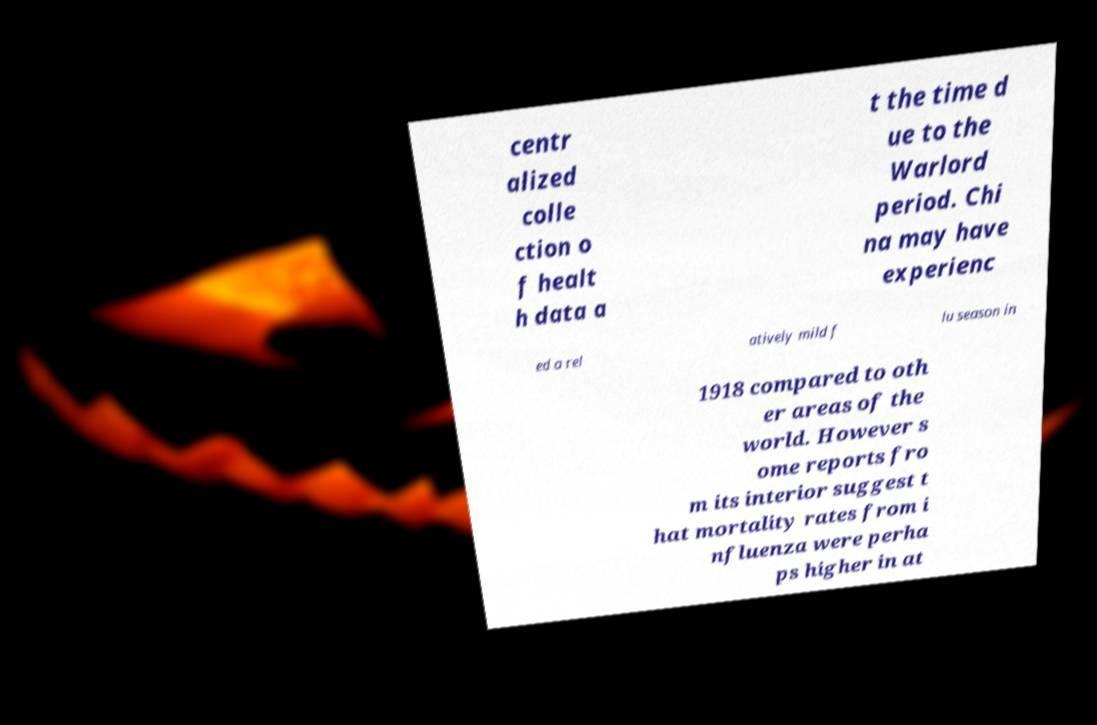Can you read and provide the text displayed in the image?This photo seems to have some interesting text. Can you extract and type it out for me? centr alized colle ction o f healt h data a t the time d ue to the Warlord period. Chi na may have experienc ed a rel atively mild f lu season in 1918 compared to oth er areas of the world. However s ome reports fro m its interior suggest t hat mortality rates from i nfluenza were perha ps higher in at 